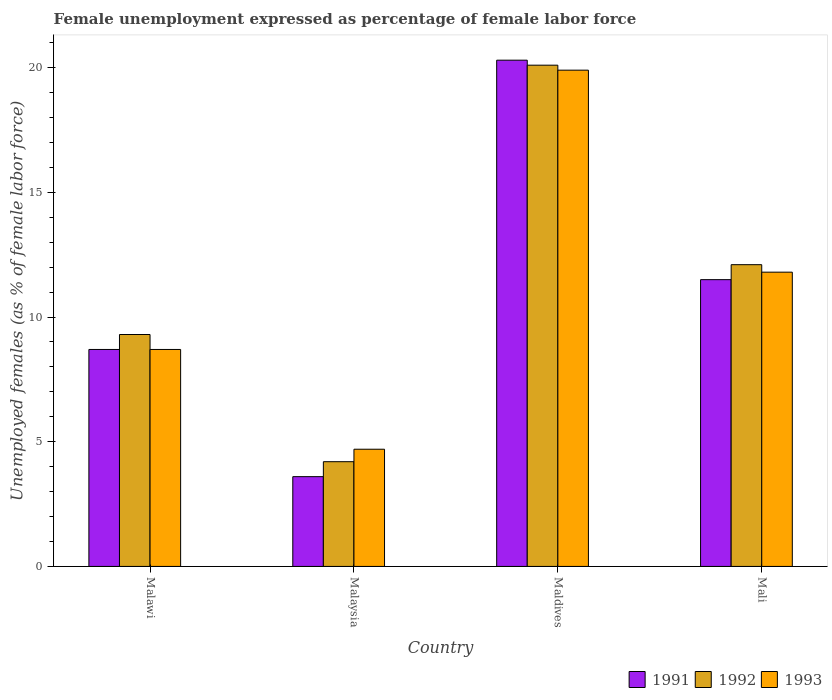How many different coloured bars are there?
Ensure brevity in your answer.  3. How many groups of bars are there?
Your response must be concise. 4. Are the number of bars per tick equal to the number of legend labels?
Provide a short and direct response. Yes. How many bars are there on the 3rd tick from the left?
Offer a very short reply. 3. What is the label of the 1st group of bars from the left?
Your answer should be compact. Malawi. In how many cases, is the number of bars for a given country not equal to the number of legend labels?
Ensure brevity in your answer.  0. What is the unemployment in females in in 1993 in Maldives?
Provide a short and direct response. 19.9. Across all countries, what is the maximum unemployment in females in in 1991?
Make the answer very short. 20.3. Across all countries, what is the minimum unemployment in females in in 1993?
Offer a terse response. 4.7. In which country was the unemployment in females in in 1991 maximum?
Make the answer very short. Maldives. In which country was the unemployment in females in in 1992 minimum?
Your response must be concise. Malaysia. What is the total unemployment in females in in 1993 in the graph?
Your response must be concise. 45.1. What is the difference between the unemployment in females in in 1993 in Maldives and that in Mali?
Your answer should be very brief. 8.1. What is the difference between the unemployment in females in in 1992 in Mali and the unemployment in females in in 1991 in Maldives?
Make the answer very short. -8.2. What is the average unemployment in females in in 1991 per country?
Make the answer very short. 11.02. What is the difference between the unemployment in females in of/in 1993 and unemployment in females in of/in 1992 in Malawi?
Provide a short and direct response. -0.6. What is the ratio of the unemployment in females in in 1993 in Malawi to that in Mali?
Your answer should be compact. 0.74. What is the difference between the highest and the second highest unemployment in females in in 1993?
Provide a short and direct response. 3.1. What is the difference between the highest and the lowest unemployment in females in in 1993?
Offer a terse response. 15.2. In how many countries, is the unemployment in females in in 1993 greater than the average unemployment in females in in 1993 taken over all countries?
Make the answer very short. 2. Is the sum of the unemployment in females in in 1992 in Malawi and Malaysia greater than the maximum unemployment in females in in 1991 across all countries?
Give a very brief answer. No. What does the 2nd bar from the left in Malaysia represents?
Offer a terse response. 1992. How many bars are there?
Your response must be concise. 12. How many countries are there in the graph?
Your response must be concise. 4. Does the graph contain any zero values?
Ensure brevity in your answer.  No. Does the graph contain grids?
Provide a succinct answer. No. Where does the legend appear in the graph?
Offer a terse response. Bottom right. How are the legend labels stacked?
Your answer should be compact. Horizontal. What is the title of the graph?
Ensure brevity in your answer.  Female unemployment expressed as percentage of female labor force. What is the label or title of the X-axis?
Offer a very short reply. Country. What is the label or title of the Y-axis?
Your answer should be very brief. Unemployed females (as % of female labor force). What is the Unemployed females (as % of female labor force) in 1991 in Malawi?
Give a very brief answer. 8.7. What is the Unemployed females (as % of female labor force) of 1992 in Malawi?
Provide a short and direct response. 9.3. What is the Unemployed females (as % of female labor force) in 1993 in Malawi?
Provide a succinct answer. 8.7. What is the Unemployed females (as % of female labor force) of 1991 in Malaysia?
Give a very brief answer. 3.6. What is the Unemployed females (as % of female labor force) in 1992 in Malaysia?
Make the answer very short. 4.2. What is the Unemployed females (as % of female labor force) of 1993 in Malaysia?
Make the answer very short. 4.7. What is the Unemployed females (as % of female labor force) in 1991 in Maldives?
Offer a very short reply. 20.3. What is the Unemployed females (as % of female labor force) of 1992 in Maldives?
Give a very brief answer. 20.1. What is the Unemployed females (as % of female labor force) in 1993 in Maldives?
Give a very brief answer. 19.9. What is the Unemployed females (as % of female labor force) in 1991 in Mali?
Ensure brevity in your answer.  11.5. What is the Unemployed females (as % of female labor force) in 1992 in Mali?
Give a very brief answer. 12.1. What is the Unemployed females (as % of female labor force) of 1993 in Mali?
Your answer should be very brief. 11.8. Across all countries, what is the maximum Unemployed females (as % of female labor force) in 1991?
Offer a terse response. 20.3. Across all countries, what is the maximum Unemployed females (as % of female labor force) of 1992?
Ensure brevity in your answer.  20.1. Across all countries, what is the maximum Unemployed females (as % of female labor force) of 1993?
Provide a succinct answer. 19.9. Across all countries, what is the minimum Unemployed females (as % of female labor force) in 1991?
Your answer should be compact. 3.6. Across all countries, what is the minimum Unemployed females (as % of female labor force) in 1992?
Offer a terse response. 4.2. Across all countries, what is the minimum Unemployed females (as % of female labor force) in 1993?
Your response must be concise. 4.7. What is the total Unemployed females (as % of female labor force) of 1991 in the graph?
Keep it short and to the point. 44.1. What is the total Unemployed females (as % of female labor force) of 1992 in the graph?
Offer a very short reply. 45.7. What is the total Unemployed females (as % of female labor force) in 1993 in the graph?
Offer a very short reply. 45.1. What is the difference between the Unemployed females (as % of female labor force) of 1991 in Malawi and that in Malaysia?
Your answer should be compact. 5.1. What is the difference between the Unemployed females (as % of female labor force) in 1992 in Malawi and that in Maldives?
Keep it short and to the point. -10.8. What is the difference between the Unemployed females (as % of female labor force) in 1993 in Malawi and that in Maldives?
Your response must be concise. -11.2. What is the difference between the Unemployed females (as % of female labor force) of 1991 in Malawi and that in Mali?
Make the answer very short. -2.8. What is the difference between the Unemployed females (as % of female labor force) of 1993 in Malawi and that in Mali?
Ensure brevity in your answer.  -3.1. What is the difference between the Unemployed females (as % of female labor force) of 1991 in Malaysia and that in Maldives?
Your response must be concise. -16.7. What is the difference between the Unemployed females (as % of female labor force) of 1992 in Malaysia and that in Maldives?
Provide a short and direct response. -15.9. What is the difference between the Unemployed females (as % of female labor force) in 1993 in Malaysia and that in Maldives?
Make the answer very short. -15.2. What is the difference between the Unemployed females (as % of female labor force) of 1991 in Malaysia and that in Mali?
Make the answer very short. -7.9. What is the difference between the Unemployed females (as % of female labor force) in 1992 in Malaysia and that in Mali?
Provide a succinct answer. -7.9. What is the difference between the Unemployed females (as % of female labor force) in 1992 in Maldives and that in Mali?
Provide a short and direct response. 8. What is the difference between the Unemployed females (as % of female labor force) of 1993 in Maldives and that in Mali?
Your response must be concise. 8.1. What is the difference between the Unemployed females (as % of female labor force) of 1991 in Malawi and the Unemployed females (as % of female labor force) of 1992 in Maldives?
Give a very brief answer. -11.4. What is the difference between the Unemployed females (as % of female labor force) in 1991 in Malawi and the Unemployed females (as % of female labor force) in 1993 in Maldives?
Your answer should be very brief. -11.2. What is the difference between the Unemployed females (as % of female labor force) of 1992 in Malawi and the Unemployed females (as % of female labor force) of 1993 in Maldives?
Your answer should be very brief. -10.6. What is the difference between the Unemployed females (as % of female labor force) in 1991 in Malawi and the Unemployed females (as % of female labor force) in 1992 in Mali?
Ensure brevity in your answer.  -3.4. What is the difference between the Unemployed females (as % of female labor force) of 1991 in Malawi and the Unemployed females (as % of female labor force) of 1993 in Mali?
Provide a succinct answer. -3.1. What is the difference between the Unemployed females (as % of female labor force) in 1991 in Malaysia and the Unemployed females (as % of female labor force) in 1992 in Maldives?
Ensure brevity in your answer.  -16.5. What is the difference between the Unemployed females (as % of female labor force) of 1991 in Malaysia and the Unemployed females (as % of female labor force) of 1993 in Maldives?
Give a very brief answer. -16.3. What is the difference between the Unemployed females (as % of female labor force) of 1992 in Malaysia and the Unemployed females (as % of female labor force) of 1993 in Maldives?
Keep it short and to the point. -15.7. What is the difference between the Unemployed females (as % of female labor force) of 1991 in Malaysia and the Unemployed females (as % of female labor force) of 1992 in Mali?
Ensure brevity in your answer.  -8.5. What is the difference between the Unemployed females (as % of female labor force) in 1991 in Maldives and the Unemployed females (as % of female labor force) in 1992 in Mali?
Your response must be concise. 8.2. What is the difference between the Unemployed females (as % of female labor force) of 1991 in Maldives and the Unemployed females (as % of female labor force) of 1993 in Mali?
Make the answer very short. 8.5. What is the average Unemployed females (as % of female labor force) in 1991 per country?
Keep it short and to the point. 11.03. What is the average Unemployed females (as % of female labor force) of 1992 per country?
Give a very brief answer. 11.43. What is the average Unemployed females (as % of female labor force) in 1993 per country?
Give a very brief answer. 11.28. What is the difference between the Unemployed females (as % of female labor force) of 1991 and Unemployed females (as % of female labor force) of 1992 in Malawi?
Provide a succinct answer. -0.6. What is the difference between the Unemployed females (as % of female labor force) in 1991 and Unemployed females (as % of female labor force) in 1992 in Malaysia?
Offer a very short reply. -0.6. What is the difference between the Unemployed females (as % of female labor force) in 1991 and Unemployed females (as % of female labor force) in 1992 in Maldives?
Provide a succinct answer. 0.2. What is the difference between the Unemployed females (as % of female labor force) of 1992 and Unemployed females (as % of female labor force) of 1993 in Mali?
Keep it short and to the point. 0.3. What is the ratio of the Unemployed females (as % of female labor force) of 1991 in Malawi to that in Malaysia?
Offer a terse response. 2.42. What is the ratio of the Unemployed females (as % of female labor force) of 1992 in Malawi to that in Malaysia?
Your response must be concise. 2.21. What is the ratio of the Unemployed females (as % of female labor force) of 1993 in Malawi to that in Malaysia?
Offer a very short reply. 1.85. What is the ratio of the Unemployed females (as % of female labor force) in 1991 in Malawi to that in Maldives?
Make the answer very short. 0.43. What is the ratio of the Unemployed females (as % of female labor force) in 1992 in Malawi to that in Maldives?
Your answer should be compact. 0.46. What is the ratio of the Unemployed females (as % of female labor force) of 1993 in Malawi to that in Maldives?
Ensure brevity in your answer.  0.44. What is the ratio of the Unemployed females (as % of female labor force) of 1991 in Malawi to that in Mali?
Ensure brevity in your answer.  0.76. What is the ratio of the Unemployed females (as % of female labor force) in 1992 in Malawi to that in Mali?
Provide a short and direct response. 0.77. What is the ratio of the Unemployed females (as % of female labor force) in 1993 in Malawi to that in Mali?
Provide a short and direct response. 0.74. What is the ratio of the Unemployed females (as % of female labor force) in 1991 in Malaysia to that in Maldives?
Make the answer very short. 0.18. What is the ratio of the Unemployed females (as % of female labor force) of 1992 in Malaysia to that in Maldives?
Provide a short and direct response. 0.21. What is the ratio of the Unemployed females (as % of female labor force) of 1993 in Malaysia to that in Maldives?
Offer a terse response. 0.24. What is the ratio of the Unemployed females (as % of female labor force) in 1991 in Malaysia to that in Mali?
Your answer should be very brief. 0.31. What is the ratio of the Unemployed females (as % of female labor force) in 1992 in Malaysia to that in Mali?
Your response must be concise. 0.35. What is the ratio of the Unemployed females (as % of female labor force) of 1993 in Malaysia to that in Mali?
Offer a terse response. 0.4. What is the ratio of the Unemployed females (as % of female labor force) of 1991 in Maldives to that in Mali?
Offer a terse response. 1.77. What is the ratio of the Unemployed females (as % of female labor force) of 1992 in Maldives to that in Mali?
Keep it short and to the point. 1.66. What is the ratio of the Unemployed females (as % of female labor force) in 1993 in Maldives to that in Mali?
Offer a very short reply. 1.69. What is the difference between the highest and the lowest Unemployed females (as % of female labor force) of 1991?
Keep it short and to the point. 16.7. 